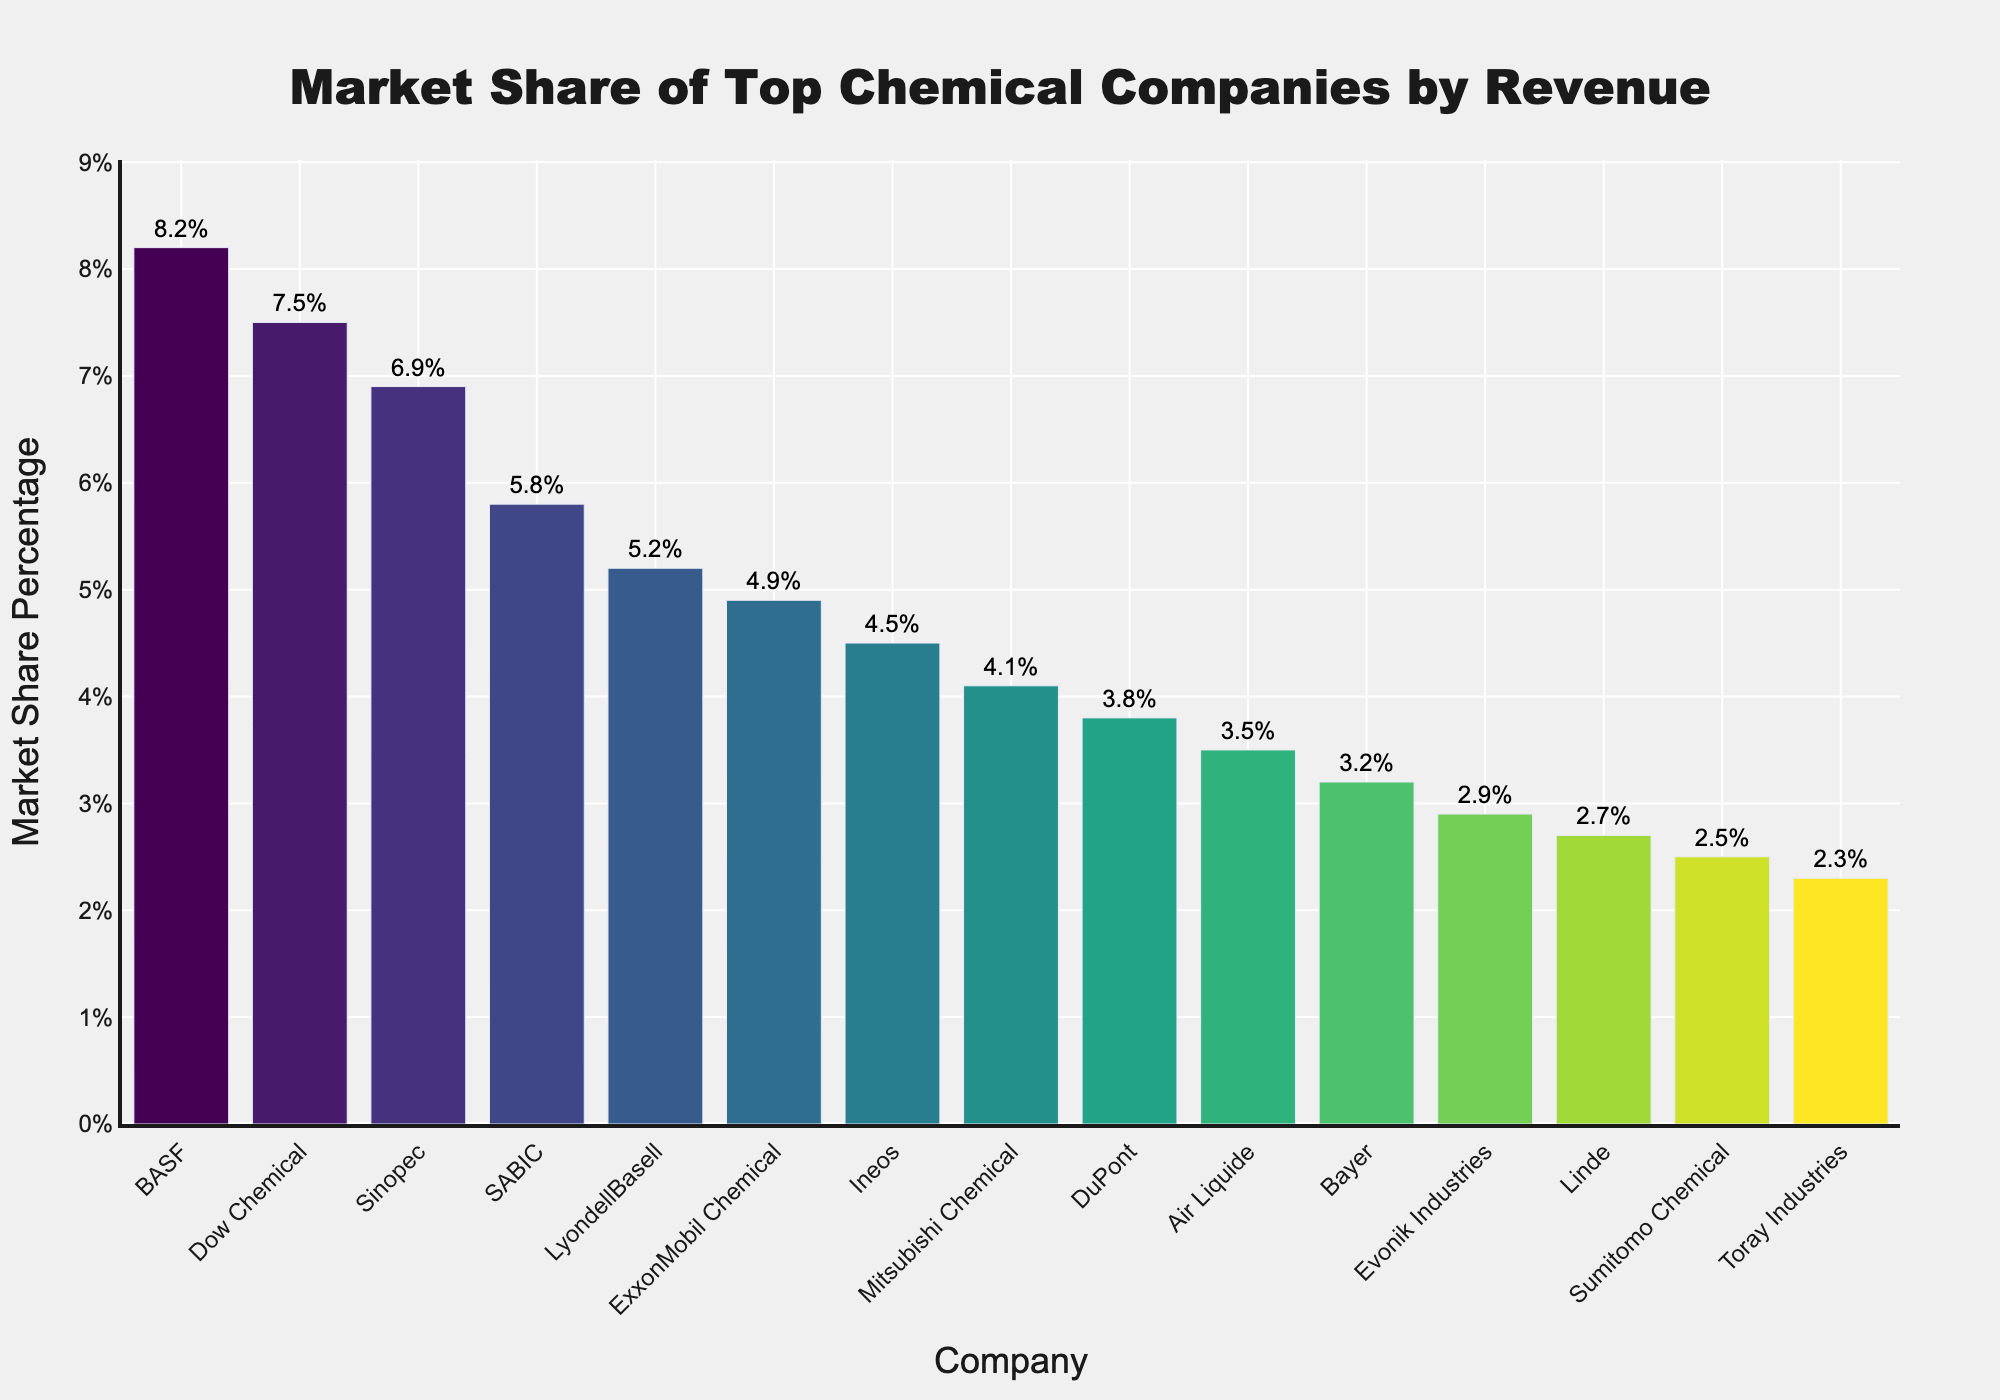what is the market share difference between the top company and the bottom company? The top company, BASF, has a market share of 8.2%, while the bottom company, Air Liquide, has 3.5%. The difference is calculated as 8.2% - 3.5% = 4.7%.
Answer: 4.7% Which company has the highest market share? The company with the highest bar in the chart represents the company with the highest market share, which is BASF with 8.2%.
Answer: BASF What are the combined market shares of BASF and Dow Chemical? Add the market shares of BASF (8.2%) and Dow Chemical (7.5%). The total is 8.2% + 7.5% = 15.7%.
Answer: 15.7% How many companies have a market share above 5%? Count the number of companies with bars that reach above the 5% mark. These companies are BASF, Dow Chemical, Sinopec, SABIC, and LyondellBasell. There are 5 companies in total.
Answer: 5 What is the average market share of the top five companies? Sum the market shares of BASF (8.2%), Dow Chemical (7.5%), Sinopec (6.9%), SABIC (5.8%), and LyondellBasell (5.2%), then divide by 5. (8.2 + 7.5 + 6.9 + 5.8 + 5.2) / 5 = 33.6 / 5 = 6.72%.
Answer: 6.72% Which company has the third lowest market share, and what is it? The third lowest market share is identified by the third shortest bar. From the sorted data, the companies are Toray Industries, Sumitomo Chemical, and Linde. Therefore, Linde has the third lowest market share at 2.7%.
Answer: Linde, 2.7% What is the total market share of all the companies shown? Sum the market shares of all companies: 8.2 + 7.5 + 6.9 + 5.8 + 5.2 + 4.9 + 4.5 + 4.1 + 3.8 + 3.5 + 3.2 + 2.9 + 2.7 + 2.5 + 2.3 = 67.0%.
Answer: 67.0% Which has a higher market share: ExxonMobil Chemical or Mitsubishi Chemical, and by how much? Compare the market shares of ExxonMobil Chemical (4.9%) and Mitsubishi Chemical (4.1%). The difference is 4.9% - 4.1% = 0.8%.
Answer: ExxonMobil Chemical by 0.8% What is the range of market share percentages among the top 10 companies? Identify the highest and lowest market share percentages among the top 10 companies. The highest is BASF at 8.2% and the lowest among the top 10 is Air Liquide at 3.5%. The range is 8.2% - 3.5% = 4.7%.
Answer: 4.7% 